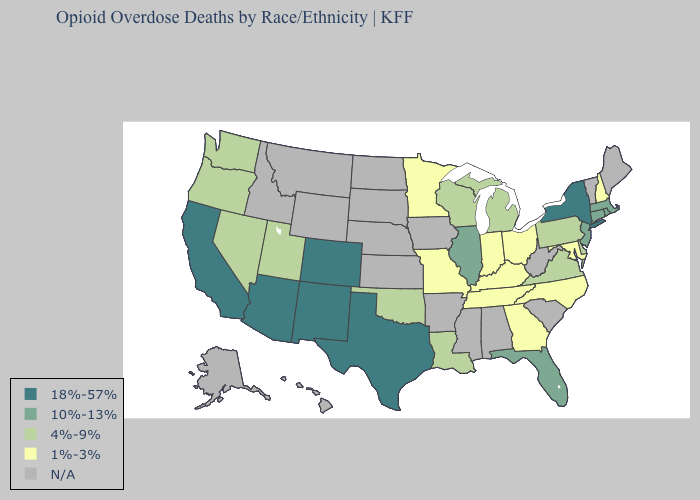What is the value of Tennessee?
Answer briefly. 1%-3%. Which states hav the highest value in the West?
Concise answer only. Arizona, California, Colorado, New Mexico. Which states hav the highest value in the South?
Quick response, please. Texas. Among the states that border Massachusetts , which have the lowest value?
Quick response, please. New Hampshire. Among the states that border New Mexico , does Utah have the lowest value?
Be succinct. Yes. What is the value of Kentucky?
Give a very brief answer. 1%-3%. What is the value of Oregon?
Short answer required. 4%-9%. Name the states that have a value in the range 1%-3%?
Write a very short answer. Georgia, Indiana, Kentucky, Maryland, Minnesota, Missouri, New Hampshire, North Carolina, Ohio, Tennessee. What is the lowest value in the West?
Concise answer only. 4%-9%. How many symbols are there in the legend?
Keep it brief. 5. What is the lowest value in the MidWest?
Be succinct. 1%-3%. Which states have the lowest value in the West?
Write a very short answer. Nevada, Oregon, Utah, Washington. What is the highest value in states that border Nebraska?
Short answer required. 18%-57%. What is the value of Louisiana?
Answer briefly. 4%-9%. 